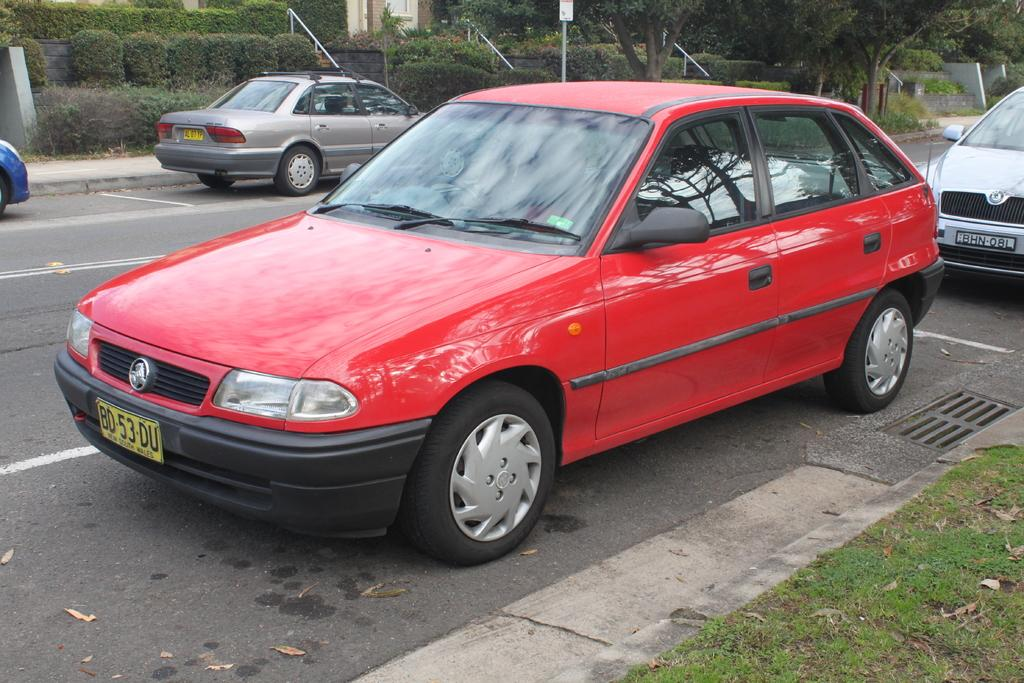What color is the car that is visible in the image? The car in the image is red. Where is the red car located in the image? The red car is on the road. Are there any other vehicles visible in the image? Yes, there are other vehicles visible on the road. How many potatoes are being harvested by the wren in the image? There are no potatoes or wrens present in the image; it features a red car on the road with other vehicles. 